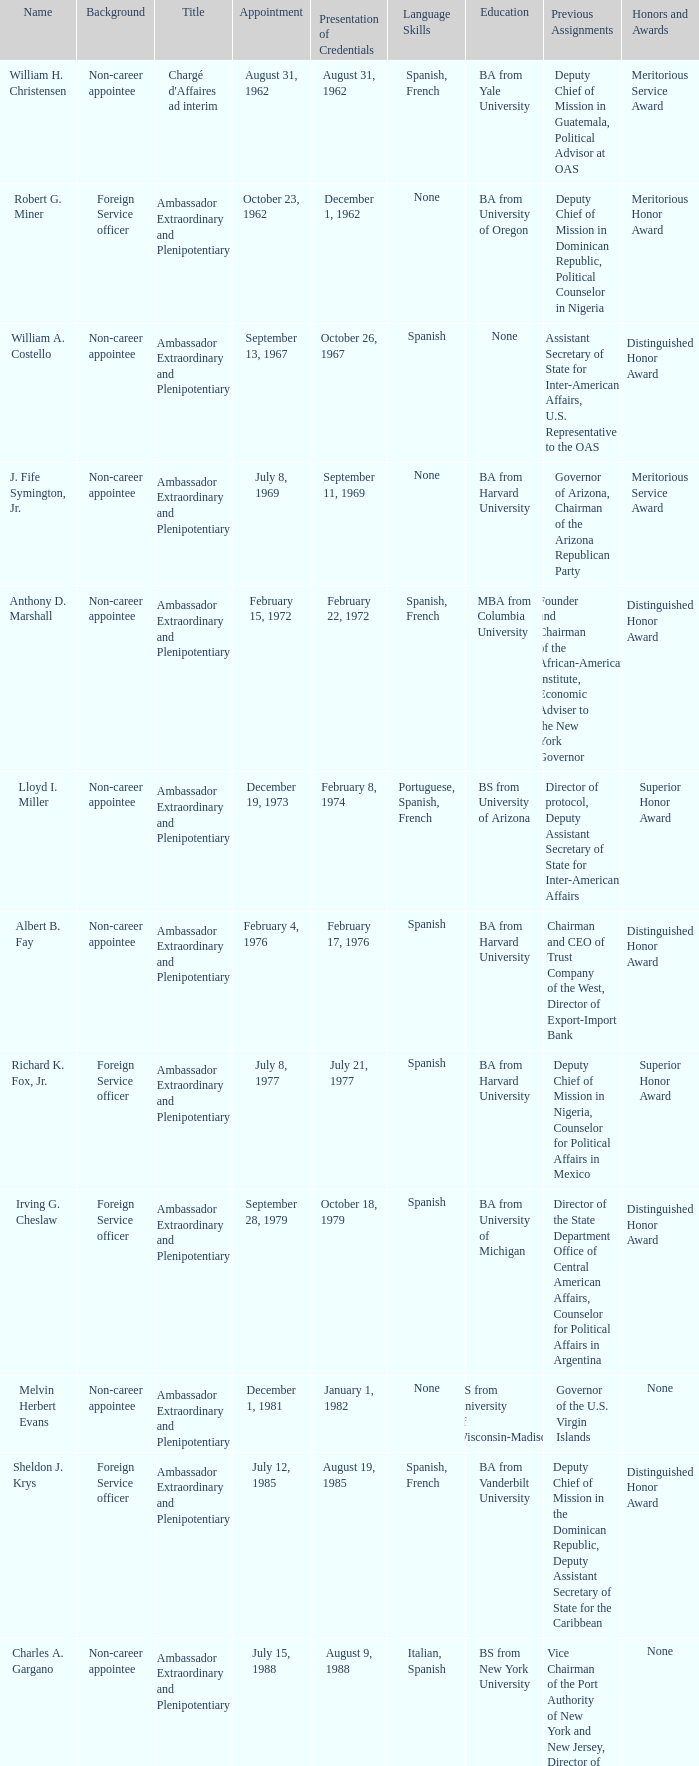When was William A. Costello appointed? September 13, 1967. 